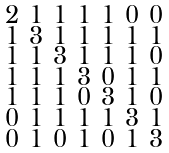<formula> <loc_0><loc_0><loc_500><loc_500>\begin{smallmatrix} 2 & 1 & 1 & 1 & 1 & 0 & 0 \\ 1 & 3 & 1 & 1 & 1 & 1 & 1 \\ 1 & 1 & 3 & 1 & 1 & 1 & 0 \\ 1 & 1 & 1 & 3 & 0 & 1 & 1 \\ 1 & 1 & 1 & 0 & 3 & 1 & 0 \\ 0 & 1 & 1 & 1 & 1 & 3 & 1 \\ 0 & 1 & 0 & 1 & 0 & 1 & 3 \end{smallmatrix}</formula> 